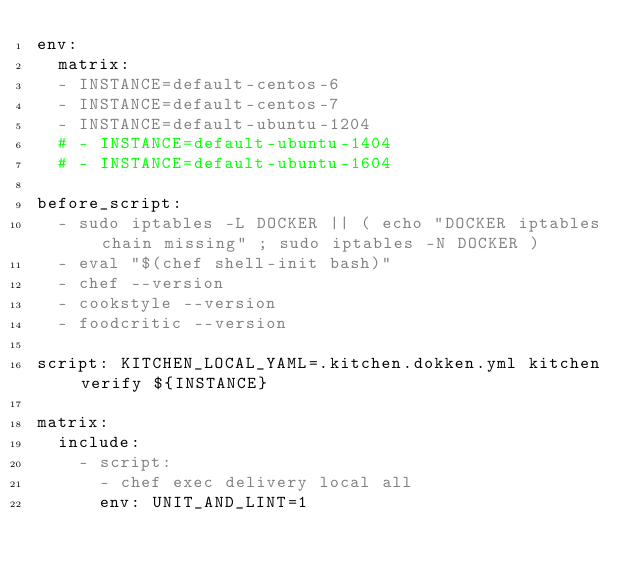<code> <loc_0><loc_0><loc_500><loc_500><_YAML_>env:
  matrix:
  - INSTANCE=default-centos-6
  - INSTANCE=default-centos-7
  - INSTANCE=default-ubuntu-1204
  # - INSTANCE=default-ubuntu-1404
  # - INSTANCE=default-ubuntu-1604

before_script:
  - sudo iptables -L DOCKER || ( echo "DOCKER iptables chain missing" ; sudo iptables -N DOCKER )
  - eval "$(chef shell-init bash)"
  - chef --version
  - cookstyle --version
  - foodcritic --version

script: KITCHEN_LOCAL_YAML=.kitchen.dokken.yml kitchen verify ${INSTANCE}

matrix:
  include:
    - script:
      - chef exec delivery local all
      env: UNIT_AND_LINT=1
</code> 